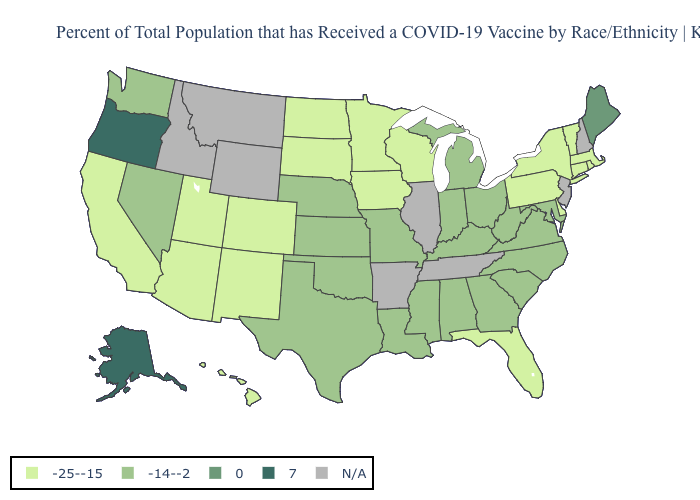Does Wisconsin have the highest value in the MidWest?
Be succinct. No. What is the value of Indiana?
Write a very short answer. -14--2. What is the highest value in states that border New Jersey?
Quick response, please. -25--15. Does the map have missing data?
Keep it brief. Yes. What is the lowest value in states that border Arizona?
Be succinct. -25--15. What is the lowest value in states that border Virginia?
Answer briefly. -14--2. What is the value of Rhode Island?
Quick response, please. -25--15. Does West Virginia have the lowest value in the South?
Write a very short answer. No. What is the value of Montana?
Keep it brief. N/A. Does Washington have the highest value in the USA?
Concise answer only. No. Name the states that have a value in the range 0?
Be succinct. Maine. Does the map have missing data?
Quick response, please. Yes. 